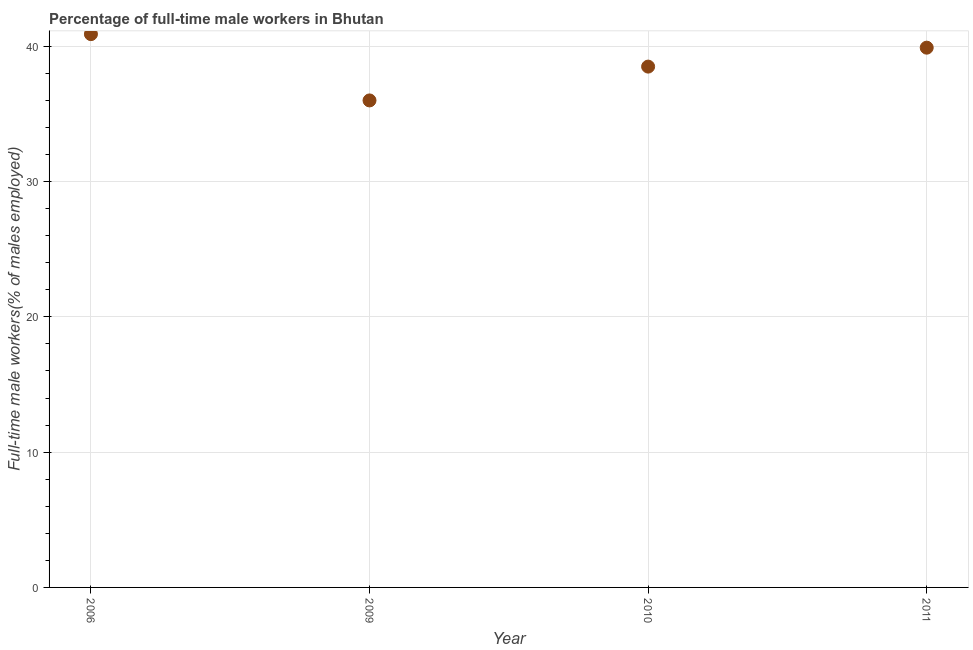What is the percentage of full-time male workers in 2011?
Offer a terse response. 39.9. Across all years, what is the maximum percentage of full-time male workers?
Provide a short and direct response. 40.9. In which year was the percentage of full-time male workers maximum?
Offer a very short reply. 2006. What is the sum of the percentage of full-time male workers?
Give a very brief answer. 155.3. What is the difference between the percentage of full-time male workers in 2006 and 2009?
Your response must be concise. 4.9. What is the average percentage of full-time male workers per year?
Make the answer very short. 38.83. What is the median percentage of full-time male workers?
Provide a succinct answer. 39.2. What is the ratio of the percentage of full-time male workers in 2006 to that in 2009?
Your response must be concise. 1.14. Is the percentage of full-time male workers in 2006 less than that in 2010?
Make the answer very short. No. What is the difference between the highest and the lowest percentage of full-time male workers?
Offer a terse response. 4.9. How many years are there in the graph?
Your response must be concise. 4. What is the title of the graph?
Your answer should be compact. Percentage of full-time male workers in Bhutan. What is the label or title of the X-axis?
Your response must be concise. Year. What is the label or title of the Y-axis?
Keep it short and to the point. Full-time male workers(% of males employed). What is the Full-time male workers(% of males employed) in 2006?
Make the answer very short. 40.9. What is the Full-time male workers(% of males employed) in 2009?
Give a very brief answer. 36. What is the Full-time male workers(% of males employed) in 2010?
Give a very brief answer. 38.5. What is the Full-time male workers(% of males employed) in 2011?
Your answer should be very brief. 39.9. What is the difference between the Full-time male workers(% of males employed) in 2006 and 2011?
Offer a very short reply. 1. What is the difference between the Full-time male workers(% of males employed) in 2009 and 2010?
Ensure brevity in your answer.  -2.5. What is the difference between the Full-time male workers(% of males employed) in 2009 and 2011?
Your answer should be very brief. -3.9. What is the ratio of the Full-time male workers(% of males employed) in 2006 to that in 2009?
Ensure brevity in your answer.  1.14. What is the ratio of the Full-time male workers(% of males employed) in 2006 to that in 2010?
Offer a terse response. 1.06. What is the ratio of the Full-time male workers(% of males employed) in 2006 to that in 2011?
Your response must be concise. 1.02. What is the ratio of the Full-time male workers(% of males employed) in 2009 to that in 2010?
Provide a short and direct response. 0.94. What is the ratio of the Full-time male workers(% of males employed) in 2009 to that in 2011?
Give a very brief answer. 0.9. What is the ratio of the Full-time male workers(% of males employed) in 2010 to that in 2011?
Offer a terse response. 0.96. 